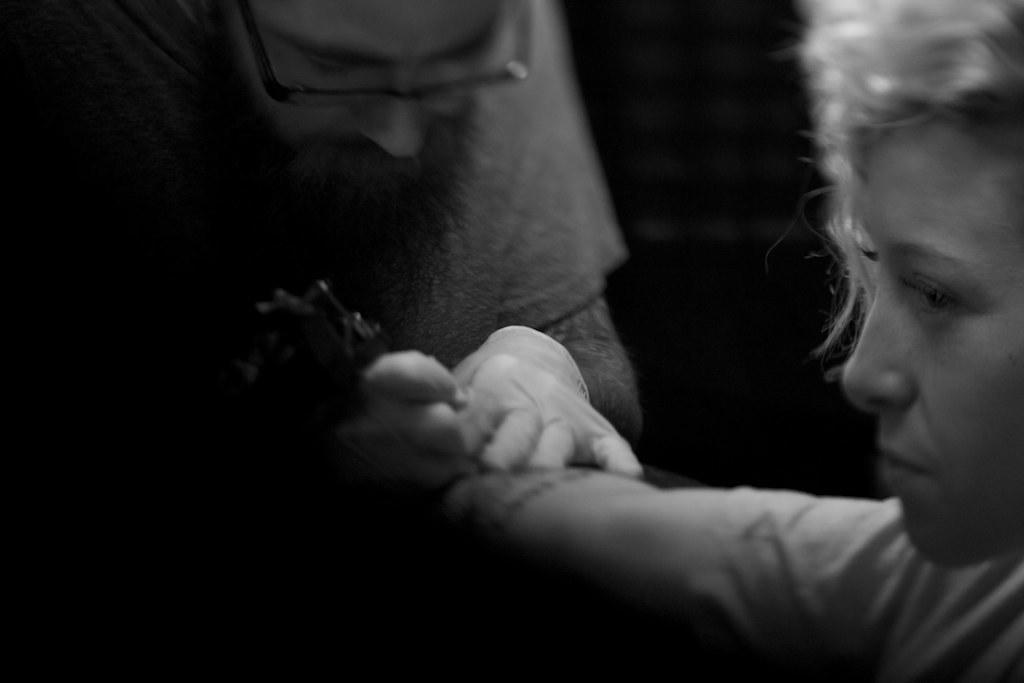Describe this image in one or two sentences. In this image there are two persons visible, one person holding an object. 